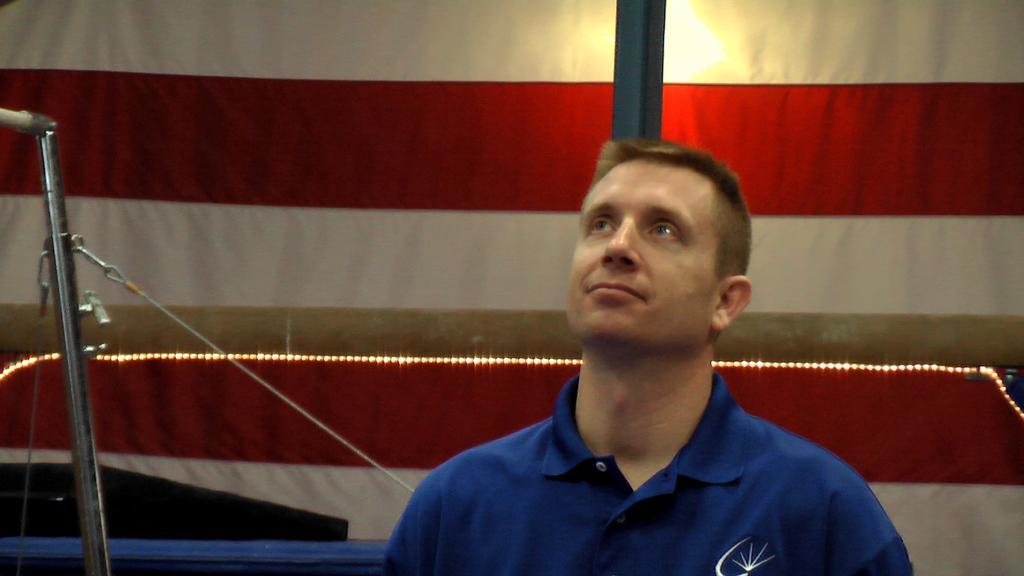Can you describe this image briefly? In this image we can see a person. There is a gymnastic beam in the image. There are few objects at the left side of the image. There is a lamp in the image. 